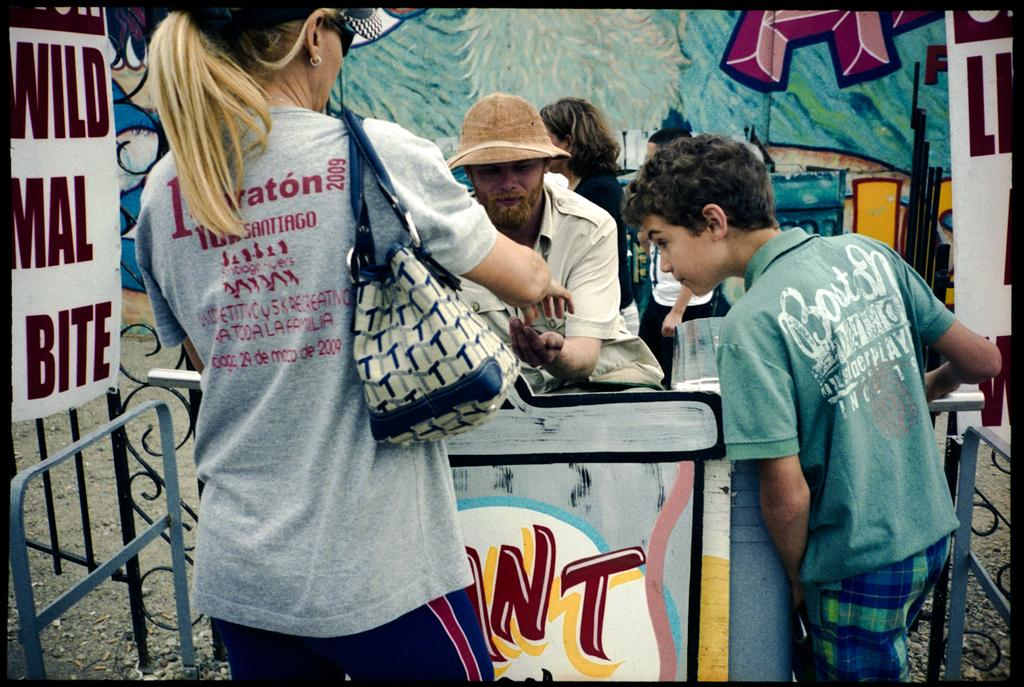How many people are in the image? There are people in the image, but the exact number is not specified. What can be seen on the banners in the image? There are two banners with text in the image. What is in the background of the image? There is an object that looks like a wall in the background. What is on the wall in the image? There is an art piece on the wall. What is the opinion of the pot on the art piece in the image? There is no pot present in the image, and therefore no such opinion can be attributed to it. 